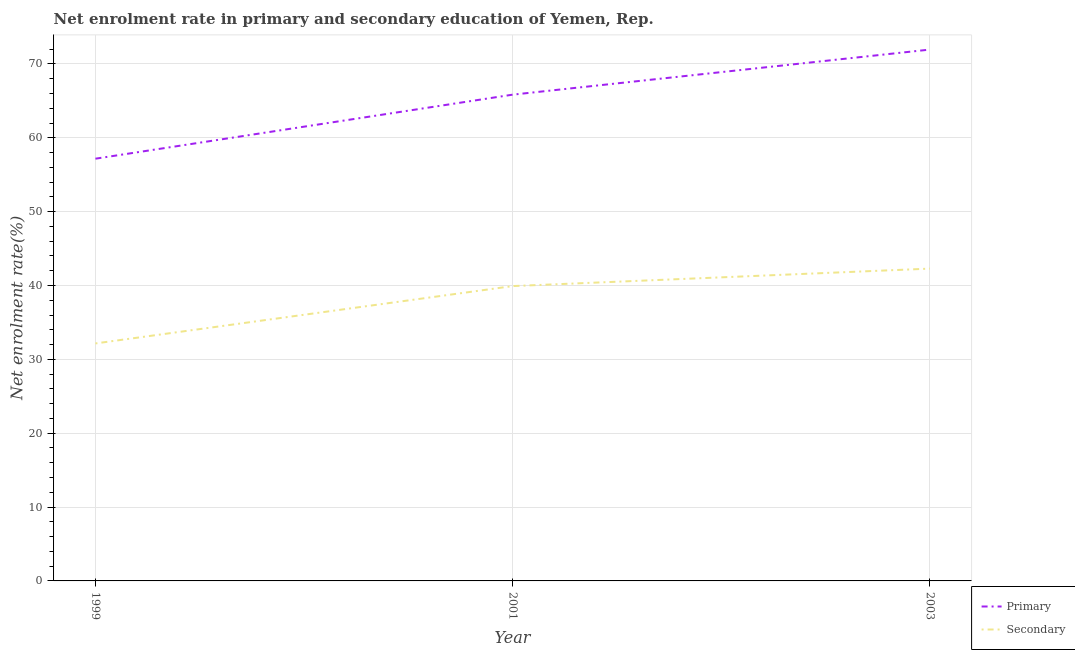How many different coloured lines are there?
Give a very brief answer. 2. Is the number of lines equal to the number of legend labels?
Ensure brevity in your answer.  Yes. What is the enrollment rate in secondary education in 2001?
Ensure brevity in your answer.  39.92. Across all years, what is the maximum enrollment rate in secondary education?
Ensure brevity in your answer.  42.29. Across all years, what is the minimum enrollment rate in primary education?
Offer a terse response. 57.17. In which year was the enrollment rate in secondary education minimum?
Your answer should be compact. 1999. What is the total enrollment rate in primary education in the graph?
Ensure brevity in your answer.  194.96. What is the difference between the enrollment rate in primary education in 2001 and that in 2003?
Your answer should be compact. -6.1. What is the difference between the enrollment rate in primary education in 1999 and the enrollment rate in secondary education in 2003?
Make the answer very short. 14.88. What is the average enrollment rate in primary education per year?
Give a very brief answer. 64.99. In the year 2003, what is the difference between the enrollment rate in primary education and enrollment rate in secondary education?
Your response must be concise. 29.66. In how many years, is the enrollment rate in secondary education greater than 60 %?
Offer a very short reply. 0. What is the ratio of the enrollment rate in secondary education in 2001 to that in 2003?
Your answer should be compact. 0.94. Is the difference between the enrollment rate in primary education in 2001 and 2003 greater than the difference between the enrollment rate in secondary education in 2001 and 2003?
Ensure brevity in your answer.  No. What is the difference between the highest and the second highest enrollment rate in primary education?
Give a very brief answer. 6.1. What is the difference between the highest and the lowest enrollment rate in primary education?
Give a very brief answer. 14.78. Does the enrollment rate in secondary education monotonically increase over the years?
Give a very brief answer. Yes. Is the enrollment rate in secondary education strictly greater than the enrollment rate in primary education over the years?
Provide a short and direct response. No. Is the enrollment rate in secondary education strictly less than the enrollment rate in primary education over the years?
Offer a very short reply. Yes. How many lines are there?
Provide a short and direct response. 2. How many years are there in the graph?
Offer a terse response. 3. What is the difference between two consecutive major ticks on the Y-axis?
Keep it short and to the point. 10. Does the graph contain any zero values?
Keep it short and to the point. No. Does the graph contain grids?
Keep it short and to the point. Yes. Where does the legend appear in the graph?
Make the answer very short. Bottom right. What is the title of the graph?
Offer a terse response. Net enrolment rate in primary and secondary education of Yemen, Rep. Does "GDP at market prices" appear as one of the legend labels in the graph?
Your answer should be very brief. No. What is the label or title of the X-axis?
Your answer should be very brief. Year. What is the label or title of the Y-axis?
Your answer should be very brief. Net enrolment rate(%). What is the Net enrolment rate(%) of Primary in 1999?
Your response must be concise. 57.17. What is the Net enrolment rate(%) in Secondary in 1999?
Provide a short and direct response. 32.16. What is the Net enrolment rate(%) in Primary in 2001?
Make the answer very short. 65.84. What is the Net enrolment rate(%) of Secondary in 2001?
Ensure brevity in your answer.  39.92. What is the Net enrolment rate(%) in Primary in 2003?
Offer a terse response. 71.95. What is the Net enrolment rate(%) in Secondary in 2003?
Offer a very short reply. 42.29. Across all years, what is the maximum Net enrolment rate(%) of Primary?
Ensure brevity in your answer.  71.95. Across all years, what is the maximum Net enrolment rate(%) of Secondary?
Give a very brief answer. 42.29. Across all years, what is the minimum Net enrolment rate(%) of Primary?
Provide a short and direct response. 57.17. Across all years, what is the minimum Net enrolment rate(%) of Secondary?
Provide a short and direct response. 32.16. What is the total Net enrolment rate(%) of Primary in the graph?
Your answer should be very brief. 194.96. What is the total Net enrolment rate(%) in Secondary in the graph?
Your answer should be compact. 114.37. What is the difference between the Net enrolment rate(%) in Primary in 1999 and that in 2001?
Your answer should be compact. -8.67. What is the difference between the Net enrolment rate(%) in Secondary in 1999 and that in 2001?
Provide a short and direct response. -7.77. What is the difference between the Net enrolment rate(%) in Primary in 1999 and that in 2003?
Your answer should be compact. -14.78. What is the difference between the Net enrolment rate(%) in Secondary in 1999 and that in 2003?
Offer a very short reply. -10.13. What is the difference between the Net enrolment rate(%) of Primary in 2001 and that in 2003?
Provide a short and direct response. -6.1. What is the difference between the Net enrolment rate(%) in Secondary in 2001 and that in 2003?
Offer a terse response. -2.37. What is the difference between the Net enrolment rate(%) of Primary in 1999 and the Net enrolment rate(%) of Secondary in 2001?
Keep it short and to the point. 17.25. What is the difference between the Net enrolment rate(%) in Primary in 1999 and the Net enrolment rate(%) in Secondary in 2003?
Your answer should be compact. 14.88. What is the difference between the Net enrolment rate(%) in Primary in 2001 and the Net enrolment rate(%) in Secondary in 2003?
Ensure brevity in your answer.  23.55. What is the average Net enrolment rate(%) in Primary per year?
Provide a succinct answer. 64.99. What is the average Net enrolment rate(%) in Secondary per year?
Provide a short and direct response. 38.12. In the year 1999, what is the difference between the Net enrolment rate(%) in Primary and Net enrolment rate(%) in Secondary?
Provide a succinct answer. 25.01. In the year 2001, what is the difference between the Net enrolment rate(%) in Primary and Net enrolment rate(%) in Secondary?
Give a very brief answer. 25.92. In the year 2003, what is the difference between the Net enrolment rate(%) of Primary and Net enrolment rate(%) of Secondary?
Provide a short and direct response. 29.66. What is the ratio of the Net enrolment rate(%) of Primary in 1999 to that in 2001?
Ensure brevity in your answer.  0.87. What is the ratio of the Net enrolment rate(%) of Secondary in 1999 to that in 2001?
Provide a short and direct response. 0.81. What is the ratio of the Net enrolment rate(%) in Primary in 1999 to that in 2003?
Make the answer very short. 0.79. What is the ratio of the Net enrolment rate(%) in Secondary in 1999 to that in 2003?
Keep it short and to the point. 0.76. What is the ratio of the Net enrolment rate(%) in Primary in 2001 to that in 2003?
Your answer should be very brief. 0.92. What is the ratio of the Net enrolment rate(%) of Secondary in 2001 to that in 2003?
Make the answer very short. 0.94. What is the difference between the highest and the second highest Net enrolment rate(%) in Primary?
Offer a very short reply. 6.1. What is the difference between the highest and the second highest Net enrolment rate(%) in Secondary?
Keep it short and to the point. 2.37. What is the difference between the highest and the lowest Net enrolment rate(%) in Primary?
Provide a short and direct response. 14.78. What is the difference between the highest and the lowest Net enrolment rate(%) of Secondary?
Provide a short and direct response. 10.13. 